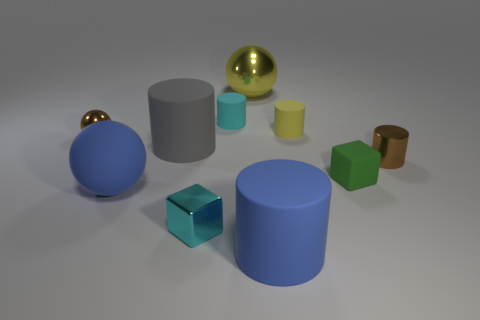Subtract all yellow spheres. How many spheres are left? 2 Subtract all brown cylinders. How many cylinders are left? 4 Subtract 3 balls. How many balls are left? 0 Subtract all blocks. How many objects are left? 8 Add 7 large matte objects. How many large matte objects exist? 10 Subtract 0 purple cubes. How many objects are left? 10 Subtract all blue cylinders. Subtract all brown spheres. How many cylinders are left? 4 Subtract all small green cubes. Subtract all brown cylinders. How many objects are left? 8 Add 2 small cyan rubber objects. How many small cyan rubber objects are left? 3 